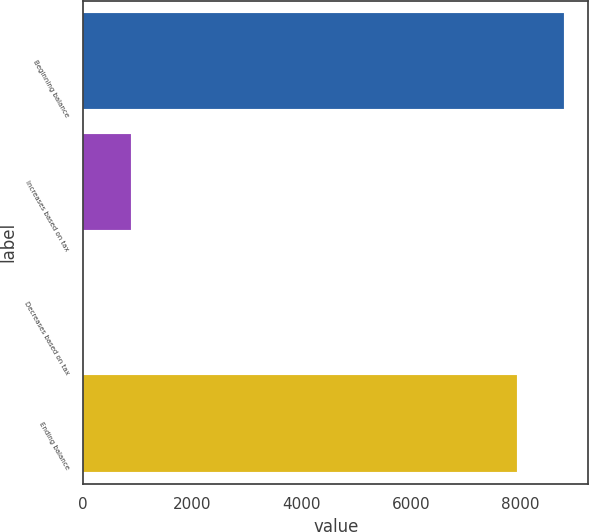Convert chart to OTSL. <chart><loc_0><loc_0><loc_500><loc_500><bar_chart><fcel>Beginning balance<fcel>Increases based on tax<fcel>Decreases based on tax<fcel>Ending balance<nl><fcel>8804.9<fcel>871.9<fcel>3<fcel>7936<nl></chart> 